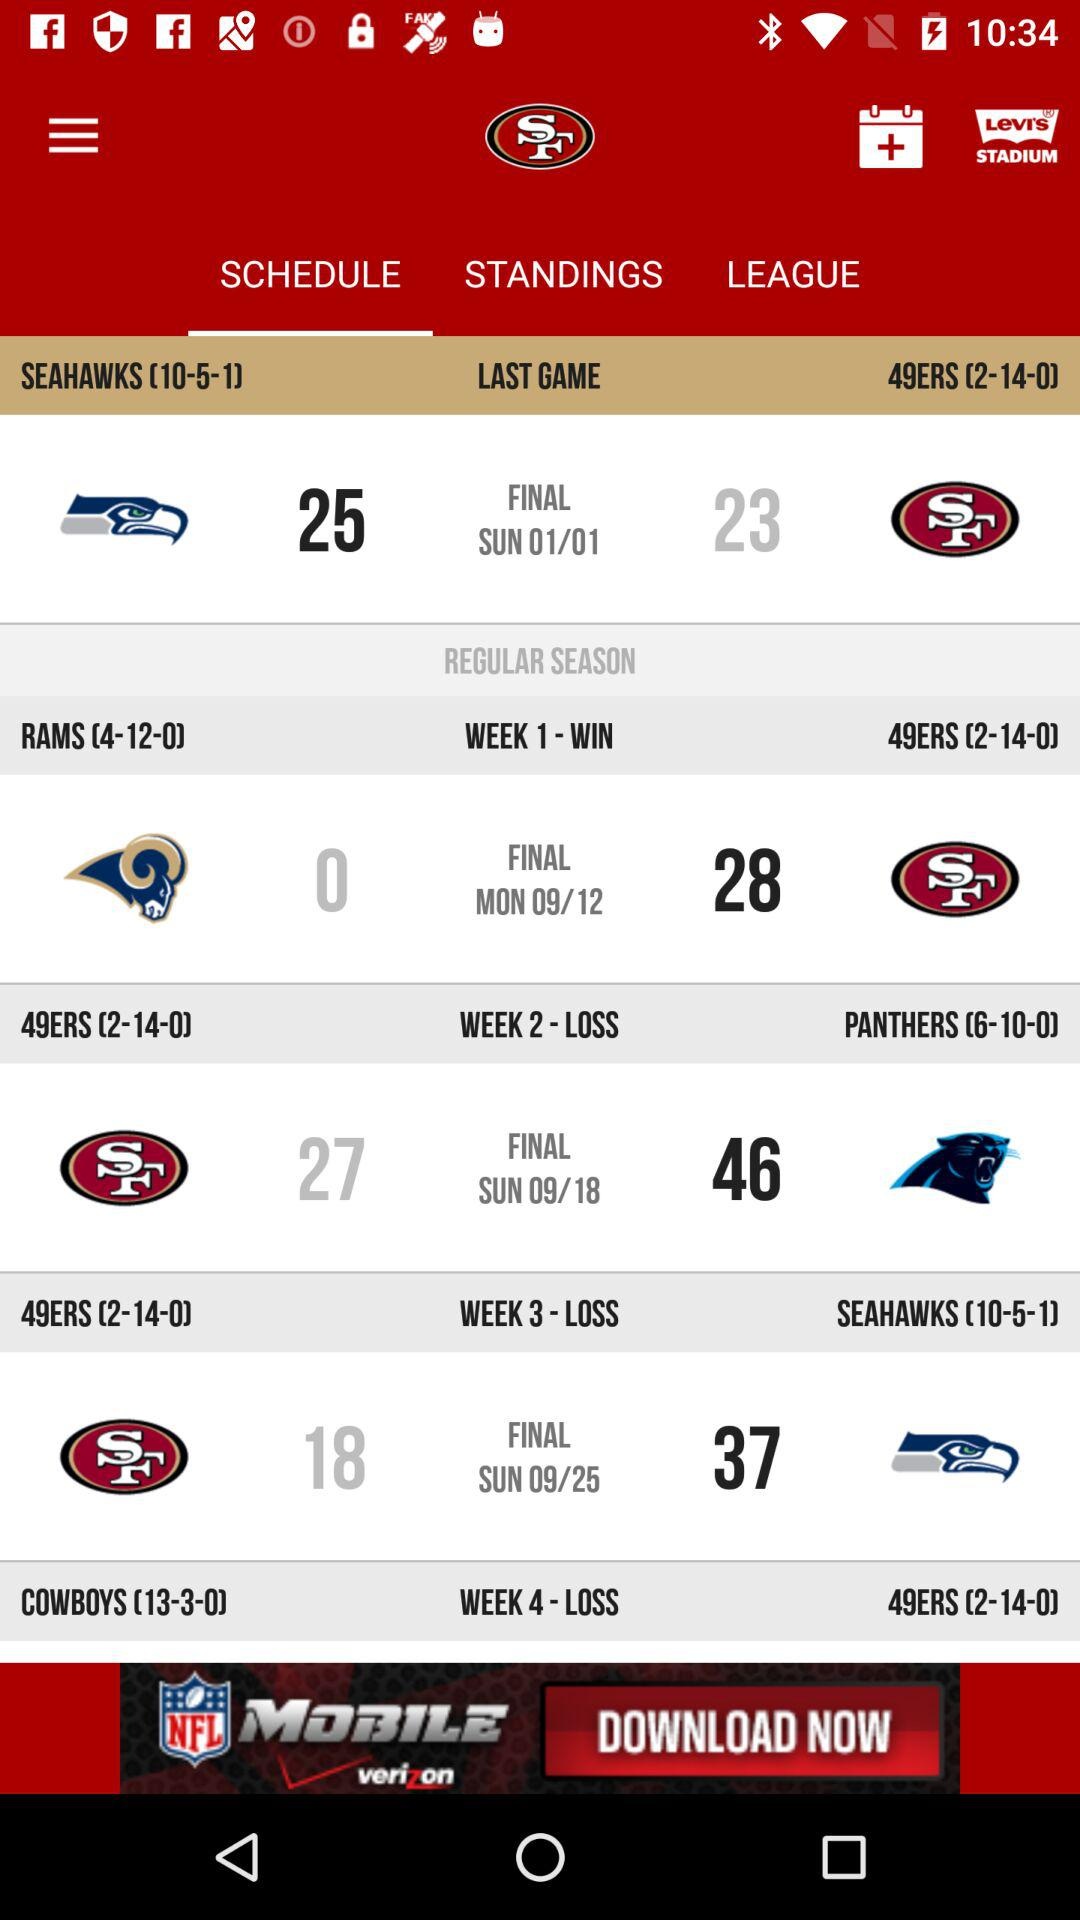What is the day on date September 18? The day is Sunday. 